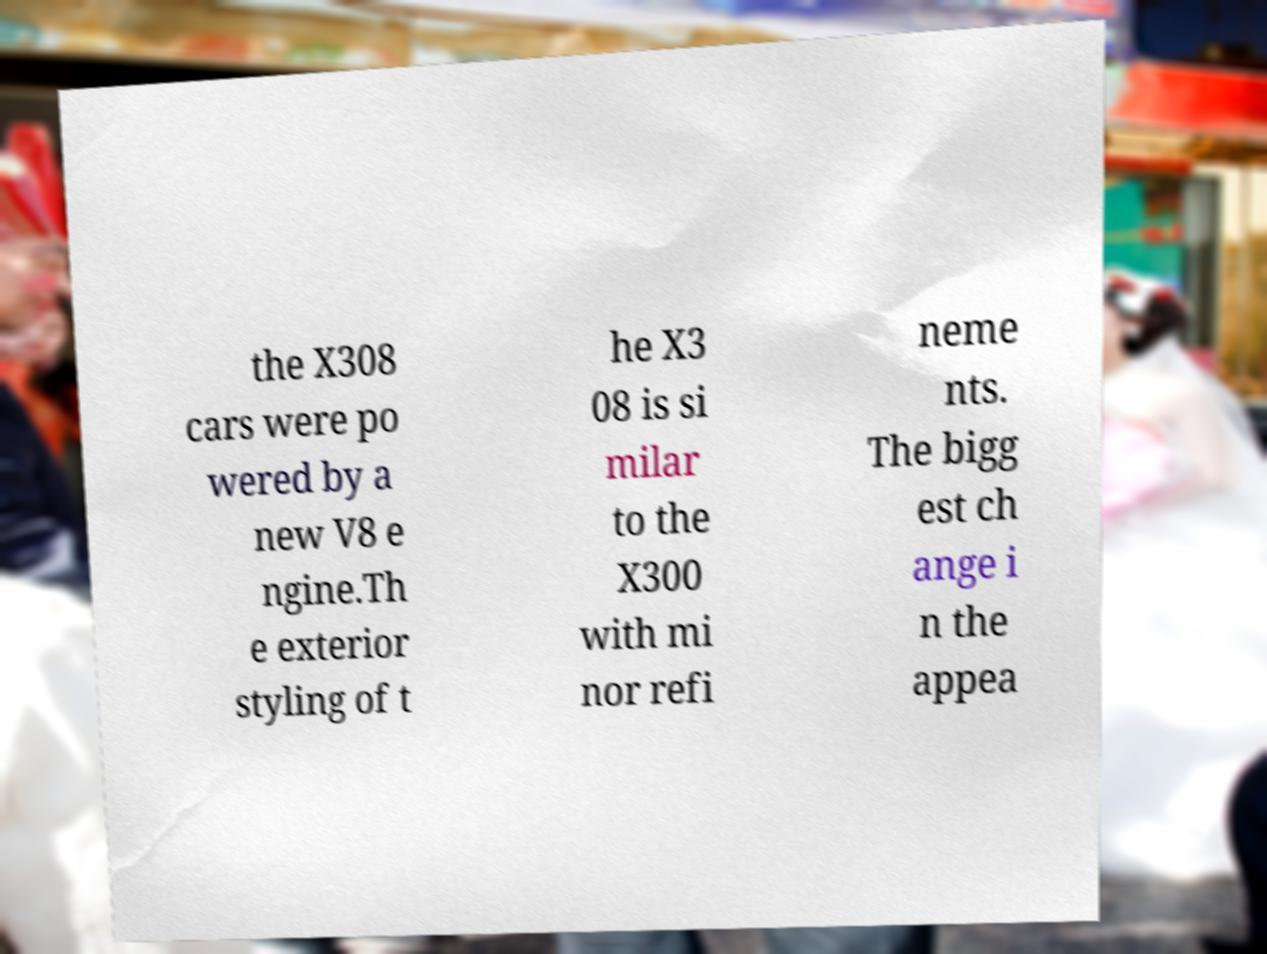Please identify and transcribe the text found in this image. the X308 cars were po wered by a new V8 e ngine.Th e exterior styling of t he X3 08 is si milar to the X300 with mi nor refi neme nts. The bigg est ch ange i n the appea 